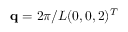Convert formula to latex. <formula><loc_0><loc_0><loc_500><loc_500>q = 2 \pi / L ( 0 , 0 , 2 ) ^ { T }</formula> 